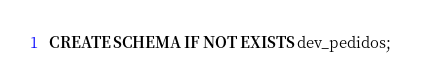<code> <loc_0><loc_0><loc_500><loc_500><_SQL_>CREATE SCHEMA IF NOT EXISTS dev_pedidos;
</code> 